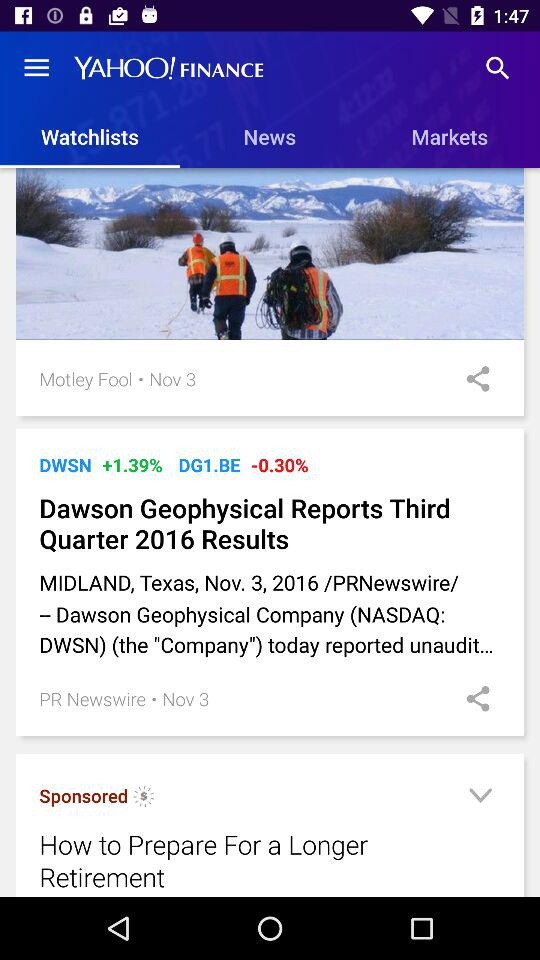What is the publication date of the article, Dawson Geophysical Reports Third Quarter 2016 Results? The publication date is November 3, 2016. 